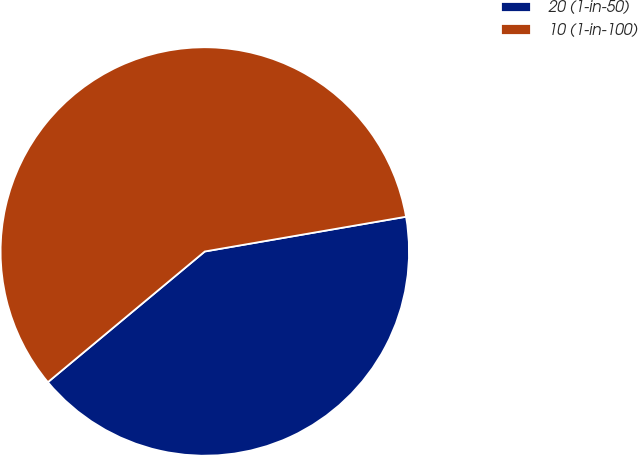Convert chart. <chart><loc_0><loc_0><loc_500><loc_500><pie_chart><fcel>20 (1-in-50)<fcel>10 (1-in-100)<nl><fcel>41.67%<fcel>58.33%<nl></chart> 